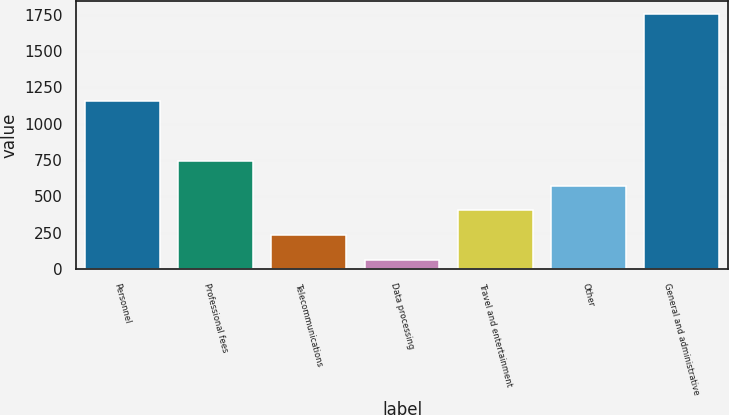Convert chart. <chart><loc_0><loc_0><loc_500><loc_500><bar_chart><fcel>Personnel<fcel>Professional fees<fcel>Telecommunications<fcel>Data processing<fcel>Travel and entertainment<fcel>Other<fcel>General and administrative<nl><fcel>1156<fcel>741<fcel>232.5<fcel>63<fcel>402<fcel>571.5<fcel>1758<nl></chart> 